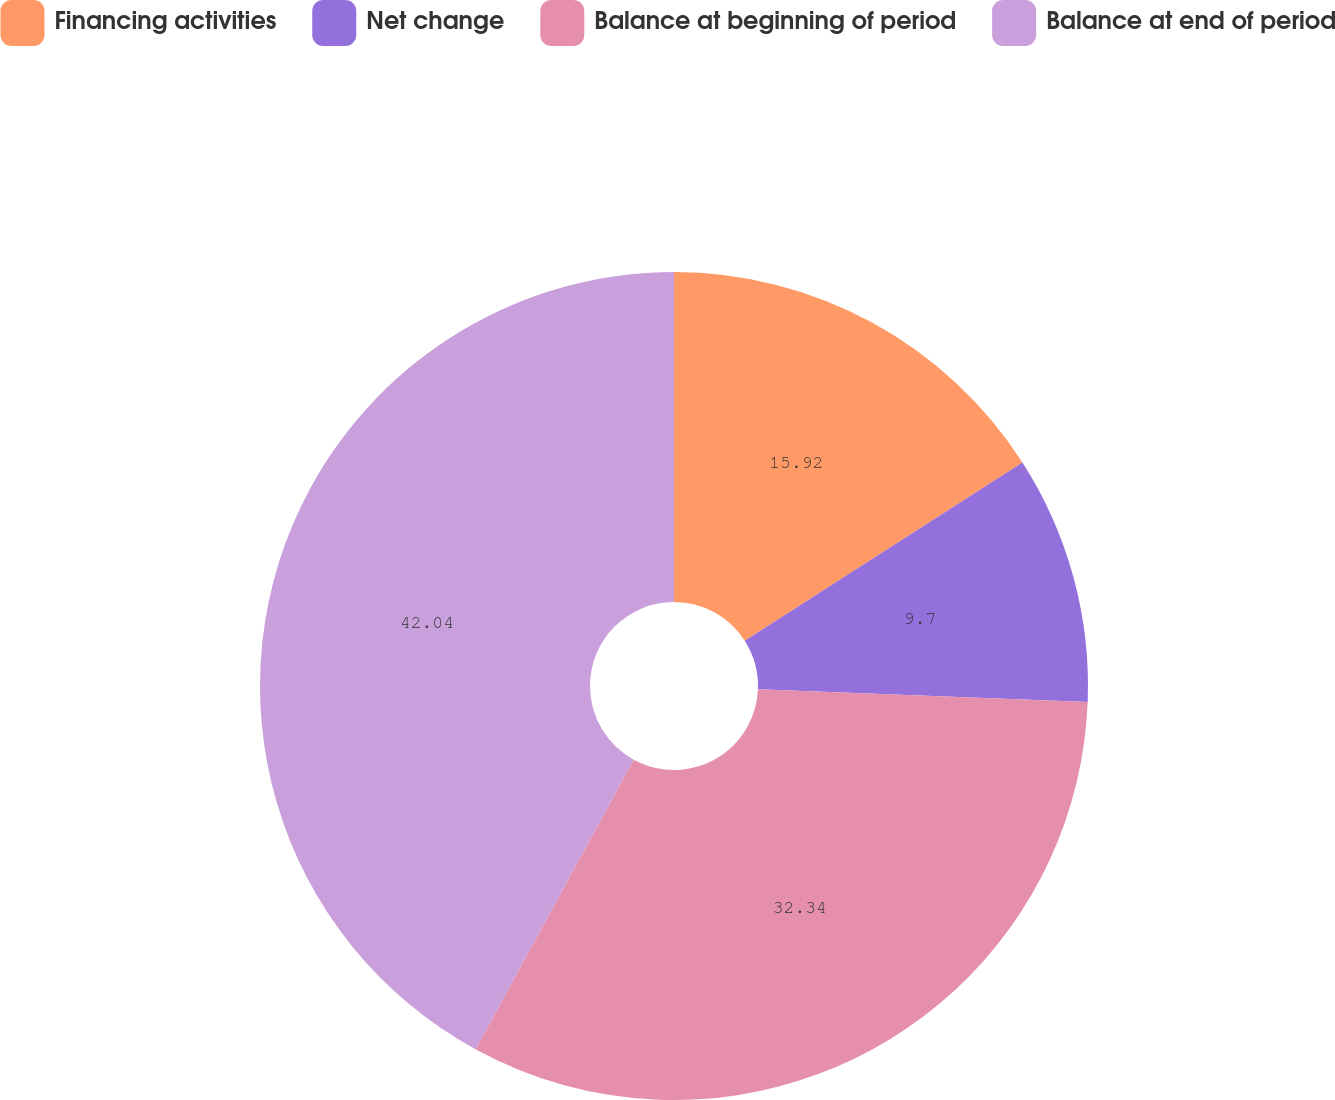<chart> <loc_0><loc_0><loc_500><loc_500><pie_chart><fcel>Financing activities<fcel>Net change<fcel>Balance at beginning of period<fcel>Balance at end of period<nl><fcel>15.92%<fcel>9.7%<fcel>32.34%<fcel>42.04%<nl></chart> 